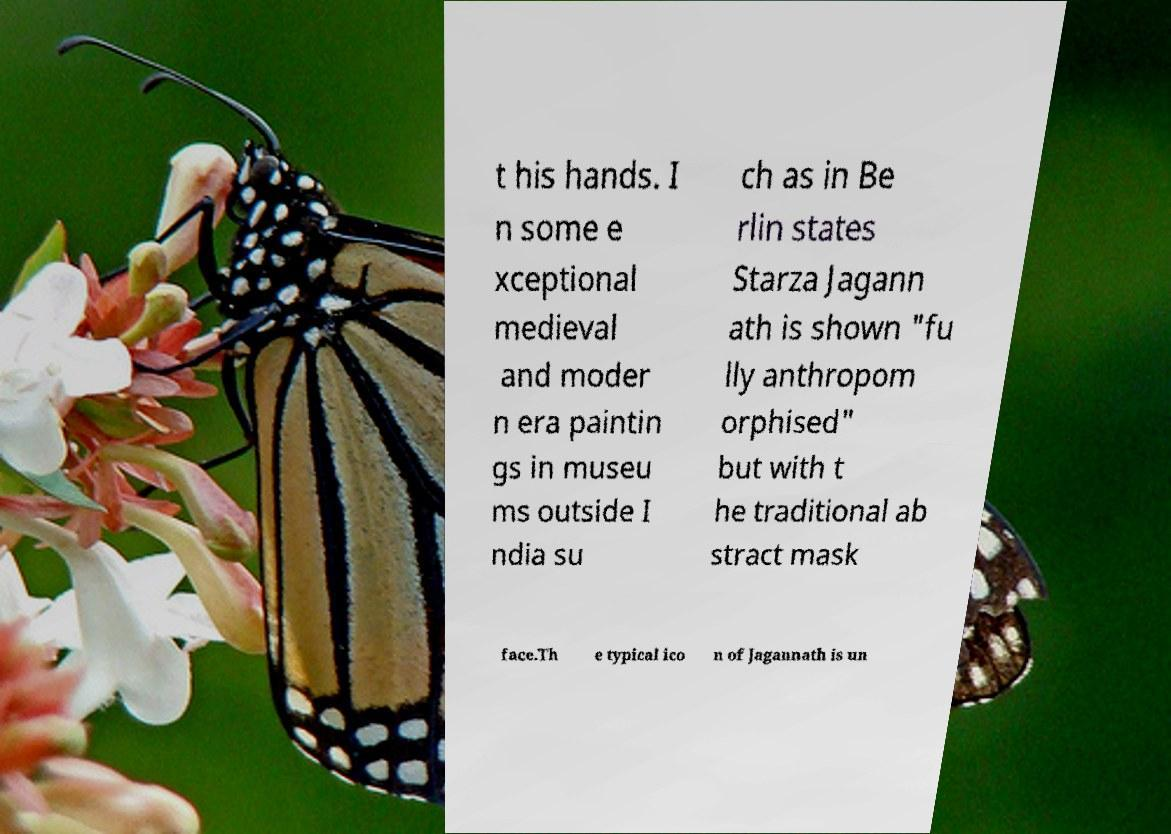Please identify and transcribe the text found in this image. t his hands. I n some e xceptional medieval and moder n era paintin gs in museu ms outside I ndia su ch as in Be rlin states Starza Jagann ath is shown "fu lly anthropom orphised" but with t he traditional ab stract mask face.Th e typical ico n of Jagannath is un 